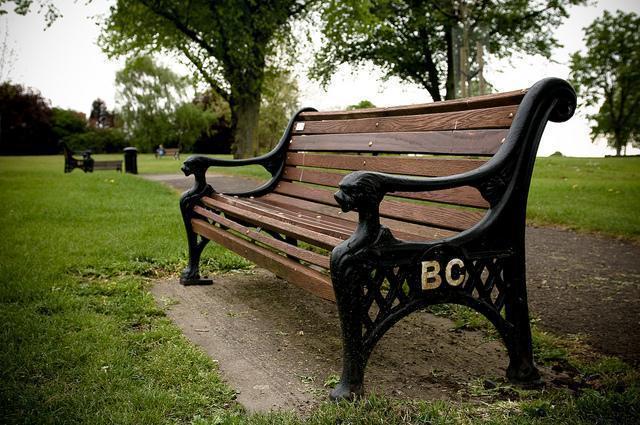What type of bench is this?
Answer the question by selecting the correct answer among the 4 following choices and explain your choice with a short sentence. The answer should be formatted with the following format: `Answer: choice
Rationale: rationale.`
Options: Blue, park, bus, chair. Answer: park.
Rationale: It is located in a park. 